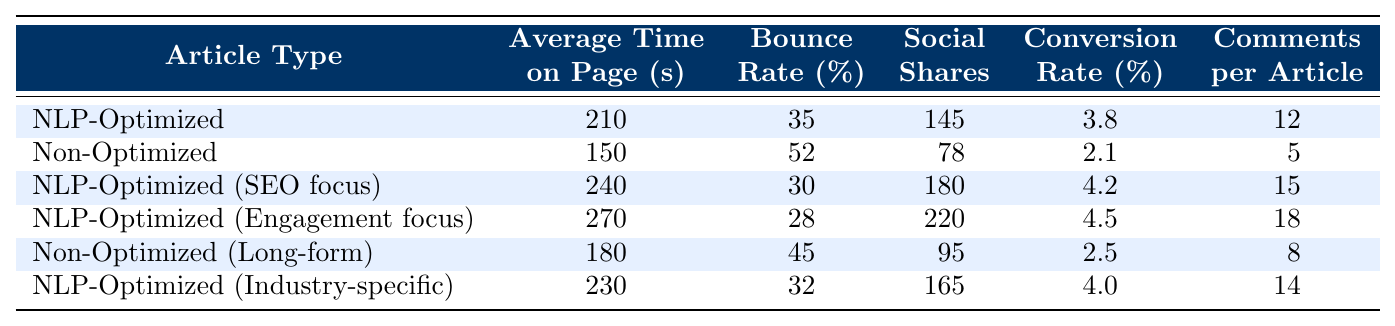What is the average time on page for NLP-optimized articles? The table shows that the average time on page for NLP-optimized articles is 210 seconds for the general category, 240 seconds for SEO focus, 270 seconds for engagement focus, and 230 seconds for industry-specific. To find the average, we sum these values: 210 + 240 + 270 + 230 = 950 seconds, and then divide by the number of articles (4). Thus, the average is 950 / 4 = 237.5 seconds.
Answer: 237.5 seconds What is the bounce rate for non-optimized articles? The table lists the bounce rate for non-optimized articles as 52% under the general category and 45% for the long-form category. We take the higher value of 52% since it captures the general performance of non-optimized articles.
Answer: 52% Which type of article has the highest social shares? According to the table, the NLP-optimized (Engagement focus) article has the highest social shares with a value of 220.
Answer: 220 What is the average conversion rate for NLP-optimized articles? The conversion rates for NLP-optimized articles are 3.8% (general), 4.2% (SEO focus), 4.5% (Engagement focus), and 4.0% (Industry-specific). We sum these: 3.8 + 4.2 + 4.5 + 4.0 = 16.5% and divide by 4 to find the average, which is 16.5 / 4 = 4.125%.
Answer: 4.125% Is the bounce rate lower for NLP-optimized articles compared to non-optimized articles? The bounce rate for NLP-optimized articles ranges from a low of 28% to a high of 35%, while non-optimized articles have a bounce rate of 52% (the highest value). Since all NLP-optimized articles have lower bounce rates than 52%, the statement is true.
Answer: Yes Which type of article has the most comments per article? The table shows the comments per article for NLP-optimized (Engagement focus) to be 18, which is the highest compared to other articles which have 12, 15, 5, 8, and 14.
Answer: 18 How many more social shares does the NLP-optimized (Engagement focus) article have compared to the non-optimized article? The NLP-optimized (Engagement focus) article has 220 social shares, while the non-optimized article has 78. To find the difference, we subtract: 220 - 78 = 142.
Answer: 142 What is the bounce rate for NLP-optimized articles with an SEO focus? The table indicates that the bounce rate for NLP-optimized articles with an SEO focus is 30%.
Answer: 30% How does the average time on page for non-optimized articles compare to that of NLP-optimized articles? The average time on page for non-optimized articles is calculated as (150 seconds for general + 180 seconds for long-form) / 2 = 165 seconds. For NLP-optimized articles, the average is 237.5 seconds calculated earlier. Since 165 is less than 237.5, the average time on page for NLP-optimized articles is higher.
Answer: NLP-optimized articles have a higher average time on page Does NLP optimization improve the conversion rate? The highest conversion rate for non-optimized articles is 2.5% (for long-form) while the lowest rate for NLP-optimized articles is 3.8% (for general). Since all NLP-optimized articles have higher conversion rates than the non-optimized article, the answer is yes.
Answer: Yes 